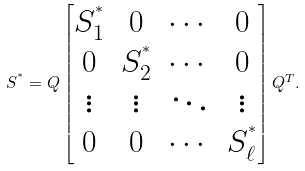<formula> <loc_0><loc_0><loc_500><loc_500>S ^ { ^ { * } } = Q \begin{bmatrix} S ^ { ^ { * } } _ { 1 } & 0 & \cdots & 0 \\ 0 & S ^ { ^ { * } } _ { 2 } & \cdots & 0 \\ \vdots & \vdots & \ddots & \vdots \\ 0 & 0 & \cdots & S ^ { ^ { * } } _ { \ell } \\ \end{bmatrix} Q ^ { T } .</formula> 